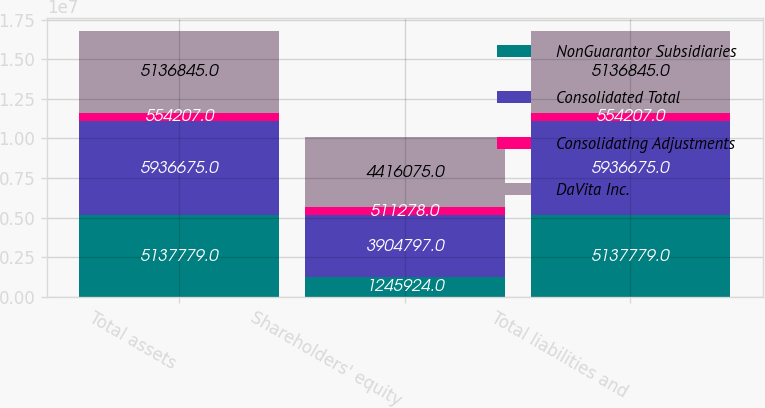Convert chart. <chart><loc_0><loc_0><loc_500><loc_500><stacked_bar_chart><ecel><fcel>Total assets<fcel>Shareholders' equity<fcel>Total liabilities and<nl><fcel>NonGuarantor Subsidiaries<fcel>5.13778e+06<fcel>1.24592e+06<fcel>5.13778e+06<nl><fcel>Consolidated Total<fcel>5.93668e+06<fcel>3.9048e+06<fcel>5.93668e+06<nl><fcel>Consolidating Adjustments<fcel>554207<fcel>511278<fcel>554207<nl><fcel>DaVita Inc.<fcel>5.13684e+06<fcel>4.41608e+06<fcel>5.13684e+06<nl></chart> 